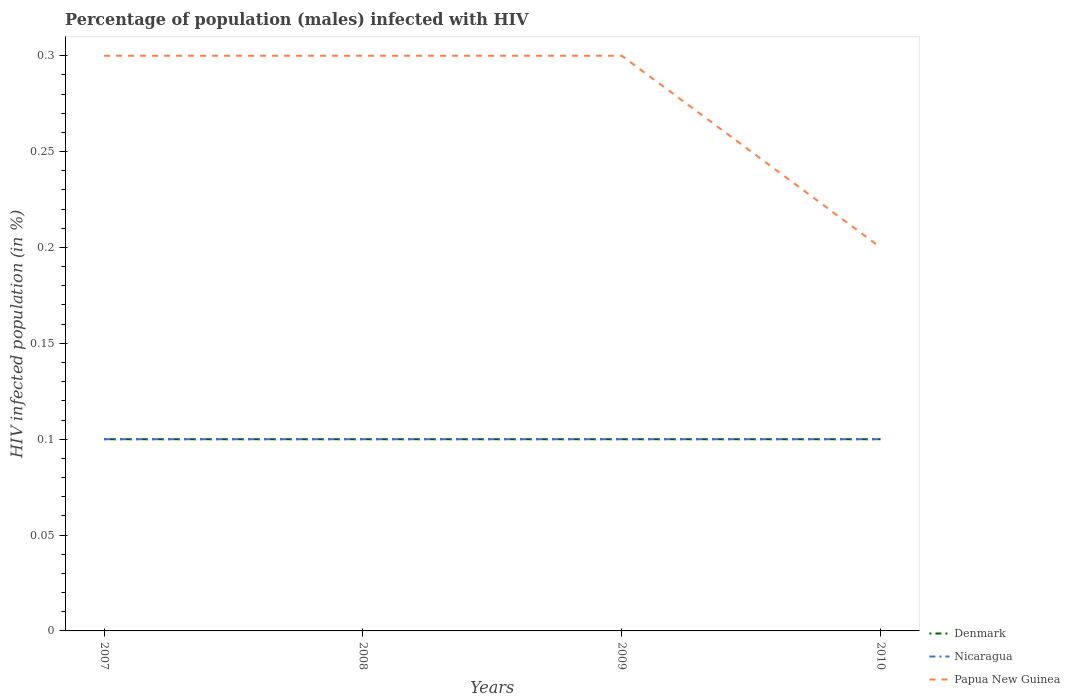How many different coloured lines are there?
Your response must be concise. 3. Does the line corresponding to Denmark intersect with the line corresponding to Papua New Guinea?
Your response must be concise. No. Is the number of lines equal to the number of legend labels?
Your response must be concise. Yes. In which year was the percentage of HIV infected male population in Nicaragua maximum?
Provide a short and direct response. 2007. What is the difference between the highest and the second highest percentage of HIV infected male population in Denmark?
Offer a terse response. 0. What is the difference between the highest and the lowest percentage of HIV infected male population in Papua New Guinea?
Keep it short and to the point. 3. How many lines are there?
Your answer should be compact. 3. How many years are there in the graph?
Give a very brief answer. 4. Does the graph contain grids?
Offer a very short reply. No. What is the title of the graph?
Make the answer very short. Percentage of population (males) infected with HIV. What is the label or title of the X-axis?
Offer a terse response. Years. What is the label or title of the Y-axis?
Give a very brief answer. HIV infected population (in %). What is the HIV infected population (in %) in Nicaragua in 2007?
Ensure brevity in your answer.  0.1. What is the HIV infected population (in %) in Papua New Guinea in 2007?
Offer a very short reply. 0.3. What is the HIV infected population (in %) in Papua New Guinea in 2008?
Keep it short and to the point. 0.3. What is the HIV infected population (in %) in Denmark in 2009?
Ensure brevity in your answer.  0.1. What is the HIV infected population (in %) of Nicaragua in 2010?
Make the answer very short. 0.1. Across all years, what is the maximum HIV infected population (in %) in Nicaragua?
Your answer should be compact. 0.1. Across all years, what is the maximum HIV infected population (in %) in Papua New Guinea?
Make the answer very short. 0.3. Across all years, what is the minimum HIV infected population (in %) in Denmark?
Your answer should be compact. 0.1. Across all years, what is the minimum HIV infected population (in %) of Nicaragua?
Provide a short and direct response. 0.1. What is the total HIV infected population (in %) in Denmark in the graph?
Make the answer very short. 0.4. What is the difference between the HIV infected population (in %) in Denmark in 2007 and that in 2008?
Your response must be concise. 0. What is the difference between the HIV infected population (in %) in Denmark in 2007 and that in 2009?
Your answer should be compact. 0. What is the difference between the HIV infected population (in %) of Nicaragua in 2007 and that in 2009?
Provide a succinct answer. 0. What is the difference between the HIV infected population (in %) of Denmark in 2007 and that in 2010?
Your answer should be compact. 0. What is the difference between the HIV infected population (in %) of Nicaragua in 2007 and that in 2010?
Your answer should be compact. 0. What is the difference between the HIV infected population (in %) in Denmark in 2008 and that in 2009?
Keep it short and to the point. 0. What is the difference between the HIV infected population (in %) of Denmark in 2008 and that in 2010?
Ensure brevity in your answer.  0. What is the difference between the HIV infected population (in %) of Nicaragua in 2008 and that in 2010?
Make the answer very short. 0. What is the difference between the HIV infected population (in %) of Papua New Guinea in 2008 and that in 2010?
Offer a very short reply. 0.1. What is the difference between the HIV infected population (in %) in Denmark in 2009 and that in 2010?
Make the answer very short. 0. What is the difference between the HIV infected population (in %) of Denmark in 2007 and the HIV infected population (in %) of Nicaragua in 2008?
Your answer should be compact. 0. What is the difference between the HIV infected population (in %) of Denmark in 2007 and the HIV infected population (in %) of Papua New Guinea in 2008?
Keep it short and to the point. -0.2. What is the difference between the HIV infected population (in %) in Nicaragua in 2007 and the HIV infected population (in %) in Papua New Guinea in 2008?
Provide a short and direct response. -0.2. What is the difference between the HIV infected population (in %) in Nicaragua in 2007 and the HIV infected population (in %) in Papua New Guinea in 2009?
Your answer should be very brief. -0.2. What is the difference between the HIV infected population (in %) in Denmark in 2007 and the HIV infected population (in %) in Nicaragua in 2010?
Make the answer very short. 0. What is the difference between the HIV infected population (in %) of Denmark in 2007 and the HIV infected population (in %) of Papua New Guinea in 2010?
Keep it short and to the point. -0.1. What is the difference between the HIV infected population (in %) in Nicaragua in 2007 and the HIV infected population (in %) in Papua New Guinea in 2010?
Your response must be concise. -0.1. What is the difference between the HIV infected population (in %) in Denmark in 2008 and the HIV infected population (in %) in Nicaragua in 2009?
Your response must be concise. 0. What is the difference between the HIV infected population (in %) in Denmark in 2008 and the HIV infected population (in %) in Nicaragua in 2010?
Offer a very short reply. 0. What is the difference between the HIV infected population (in %) of Nicaragua in 2008 and the HIV infected population (in %) of Papua New Guinea in 2010?
Provide a short and direct response. -0.1. What is the difference between the HIV infected population (in %) of Denmark in 2009 and the HIV infected population (in %) of Nicaragua in 2010?
Provide a short and direct response. 0. What is the difference between the HIV infected population (in %) in Denmark in 2009 and the HIV infected population (in %) in Papua New Guinea in 2010?
Make the answer very short. -0.1. What is the difference between the HIV infected population (in %) in Nicaragua in 2009 and the HIV infected population (in %) in Papua New Guinea in 2010?
Your answer should be very brief. -0.1. What is the average HIV infected population (in %) of Nicaragua per year?
Provide a short and direct response. 0.1. What is the average HIV infected population (in %) of Papua New Guinea per year?
Offer a very short reply. 0.28. In the year 2008, what is the difference between the HIV infected population (in %) in Denmark and HIV infected population (in %) in Nicaragua?
Your response must be concise. 0. In the year 2008, what is the difference between the HIV infected population (in %) of Nicaragua and HIV infected population (in %) of Papua New Guinea?
Your response must be concise. -0.2. In the year 2009, what is the difference between the HIV infected population (in %) of Denmark and HIV infected population (in %) of Nicaragua?
Your answer should be compact. 0. In the year 2009, what is the difference between the HIV infected population (in %) of Denmark and HIV infected population (in %) of Papua New Guinea?
Give a very brief answer. -0.2. In the year 2010, what is the difference between the HIV infected population (in %) of Denmark and HIV infected population (in %) of Nicaragua?
Give a very brief answer. 0. What is the ratio of the HIV infected population (in %) of Denmark in 2007 to that in 2008?
Your response must be concise. 1. What is the ratio of the HIV infected population (in %) in Nicaragua in 2007 to that in 2008?
Your answer should be very brief. 1. What is the ratio of the HIV infected population (in %) of Papua New Guinea in 2007 to that in 2008?
Your answer should be compact. 1. What is the ratio of the HIV infected population (in %) in Denmark in 2007 to that in 2009?
Offer a terse response. 1. What is the ratio of the HIV infected population (in %) in Papua New Guinea in 2007 to that in 2009?
Offer a very short reply. 1. What is the ratio of the HIV infected population (in %) of Denmark in 2008 to that in 2009?
Your answer should be compact. 1. What is the ratio of the HIV infected population (in %) of Nicaragua in 2008 to that in 2009?
Your response must be concise. 1. What is the ratio of the HIV infected population (in %) in Denmark in 2008 to that in 2010?
Your answer should be compact. 1. What is the ratio of the HIV infected population (in %) in Nicaragua in 2008 to that in 2010?
Offer a very short reply. 1. What is the ratio of the HIV infected population (in %) of Denmark in 2009 to that in 2010?
Your response must be concise. 1. What is the ratio of the HIV infected population (in %) of Papua New Guinea in 2009 to that in 2010?
Your answer should be very brief. 1.5. What is the difference between the highest and the second highest HIV infected population (in %) in Denmark?
Ensure brevity in your answer.  0. What is the difference between the highest and the second highest HIV infected population (in %) of Nicaragua?
Provide a short and direct response. 0. What is the difference between the highest and the lowest HIV infected population (in %) in Papua New Guinea?
Make the answer very short. 0.1. 